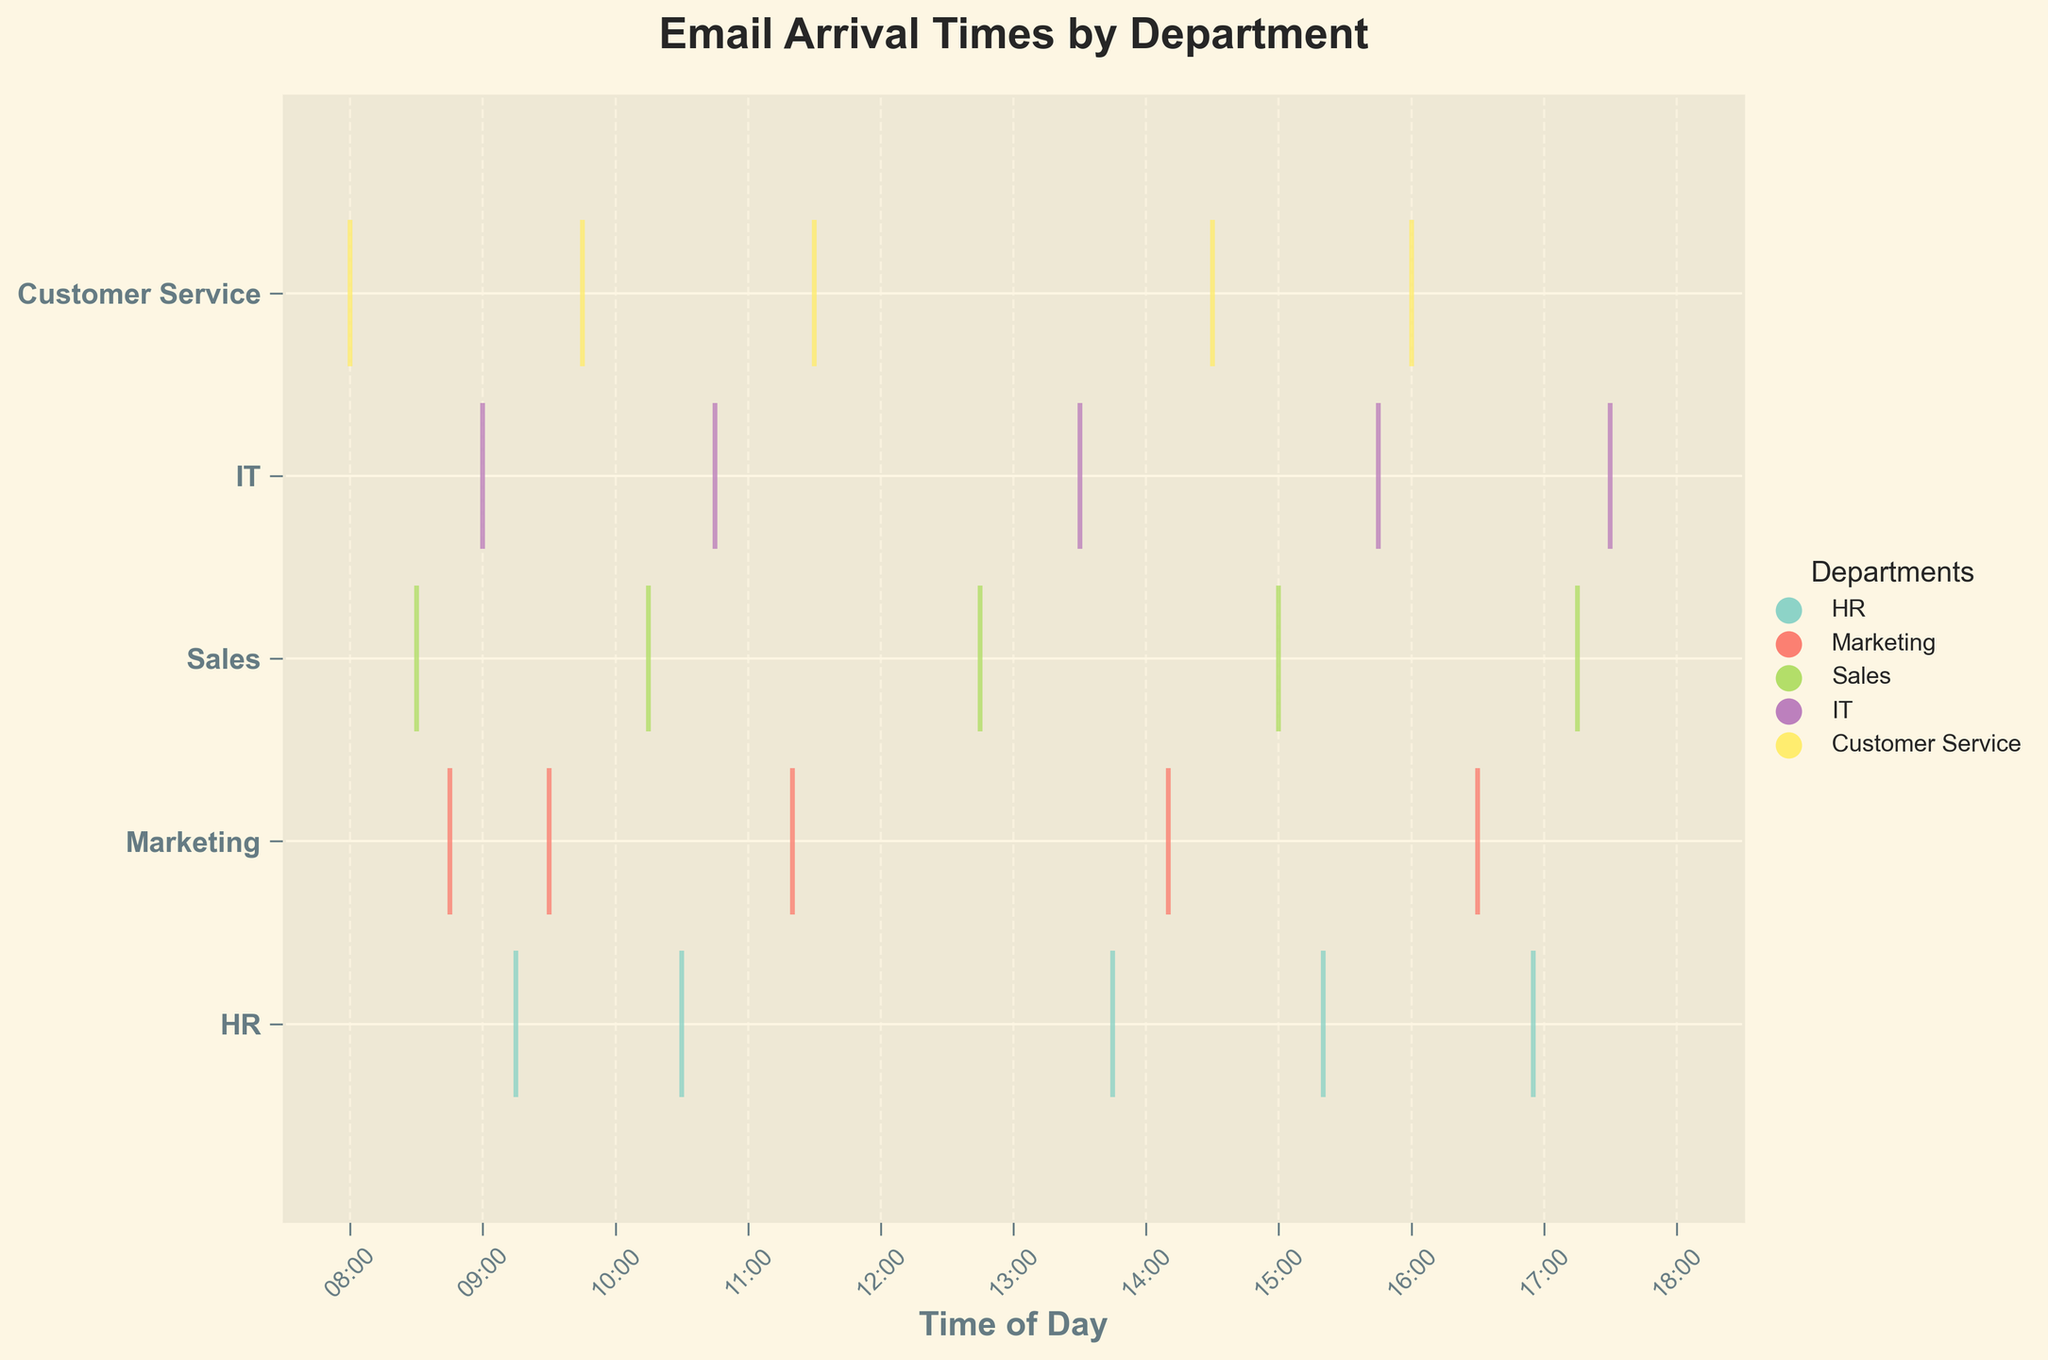What is the title of the figure? The title is typically placed at the top center of the figure and is meant to describe the main point or subject. Here it is clearly written as, "Email Arrival Times by Department".
Answer: Email Arrival Times by Department What time range is displayed on the x-axis? The x-axis represents the time of day, which runs from approximately 08:00 to 18:30. This can be deduced from the first and last labels on the x-axis (08:00 and 18:00) and the extended axis limits.
Answer: 08:00 to 18:30 How many emails were received by the HR department? Each vertical line within the HR segment of the plot represents a single email arrival time. By counting these lines, we see that HR received emails at five different times.
Answer: 5 Which department received the earliest email, and at what time? The earliest email can be determined by finding the earliest point on the x-axis among all departments. This point belongs to Customer Service at 08:00.
Answer: Customer Service at 08:00 Which department has the most dispersed email arrival times throughout the day? By looking at the spread of the vertical lines for each department, Customer Service has the most dispersed email arrival times from 08:00 to 16:00, a full-day range compared to others.
Answer: Customer Service How do email arrival times for IT at 09:00 compare to those for Marketing at 09:30? To compare, locate the times on the x-axis and observe the events for both departments. IT has an email arrival at 09:00 while Marketing has one at 09:30. Therefore, IT receives an email earlier by 30 minutes.
Answer: IT is 30 minutes earlier What is the spread (time difference) of email arrivals in the Sales department? The earliest and latest emails in Sales can be found at 08:30 and 17:15, respectively. The spread is calculated as the difference between these times, 17:15 - 08:30, which is 8 hours and 45 minutes.
Answer: 8 hours 45 minutes How many departments received emails before 09:00? By looking at the x-axis intervals and the positions of the event lines, emails were received before 09:00 by Marketing, Sales, and Customer Service.
Answer: 3 departments Do any departments receive emails after 17:00? By examining the rightmost side of the plot, we see that both Sales and IT have email arrivals after 17:00.
Answer: Yes During which hours does the majority of email traffic occur? By noting the density of event lines across all departments, most emails arrive between 09:00 and 15:00. This time range has the highest concentration of email activities.
Answer: 09:00 to 15:00 